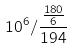Convert formula to latex. <formula><loc_0><loc_0><loc_500><loc_500>1 0 ^ { 6 } / \frac { \frac { 1 8 0 } { 6 } } { 1 9 4 }</formula> 